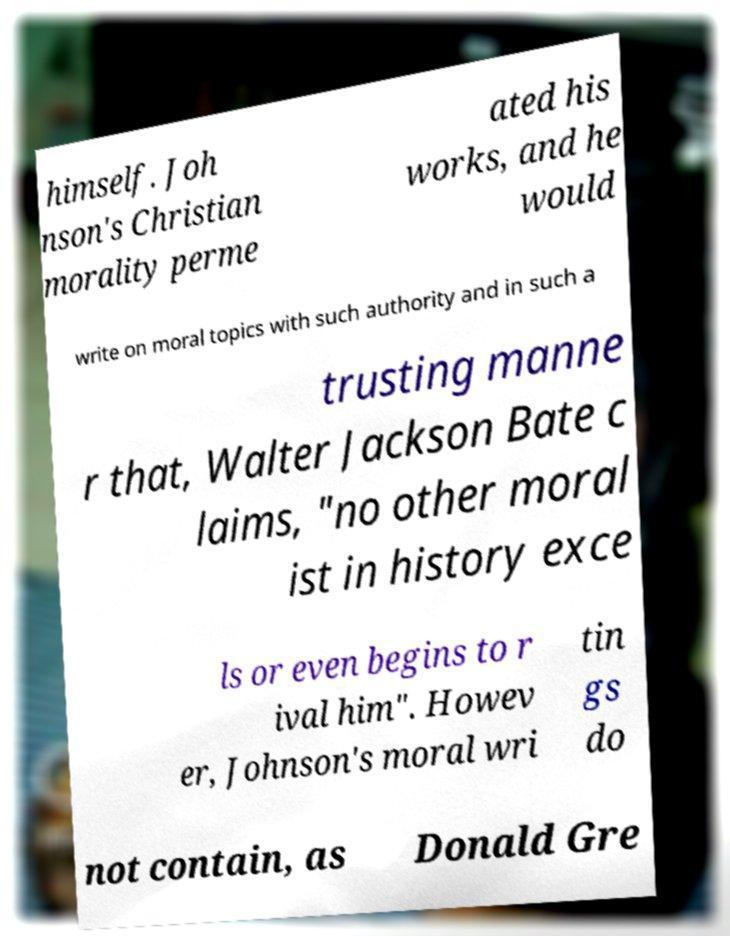Please identify and transcribe the text found in this image. himself. Joh nson's Christian morality perme ated his works, and he would write on moral topics with such authority and in such a trusting manne r that, Walter Jackson Bate c laims, "no other moral ist in history exce ls or even begins to r ival him". Howev er, Johnson's moral wri tin gs do not contain, as Donald Gre 